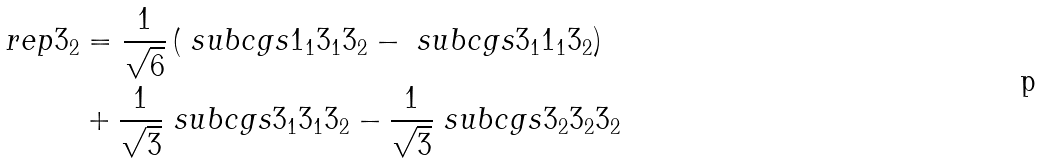Convert formula to latex. <formula><loc_0><loc_0><loc_500><loc_500>\ r e p { 3 } _ { 2 } & = \frac { 1 } { \sqrt { 6 } } \left ( \ s u b c g s { 1 _ { 1 } } { 3 _ { 1 } } { 3 _ { 2 } } - \ s u b c g s { 3 _ { 1 } } { 1 _ { 1 } } { 3 _ { 2 } } \right ) \\ & + \frac { 1 } { \sqrt { 3 } } \ s u b c g s { 3 _ { 1 } } { 3 _ { 1 } } { 3 _ { 2 } } - \frac { 1 } { \sqrt { 3 } } \ s u b c g s { 3 _ { 2 } } { 3 _ { 2 } } { 3 _ { 2 } }</formula> 